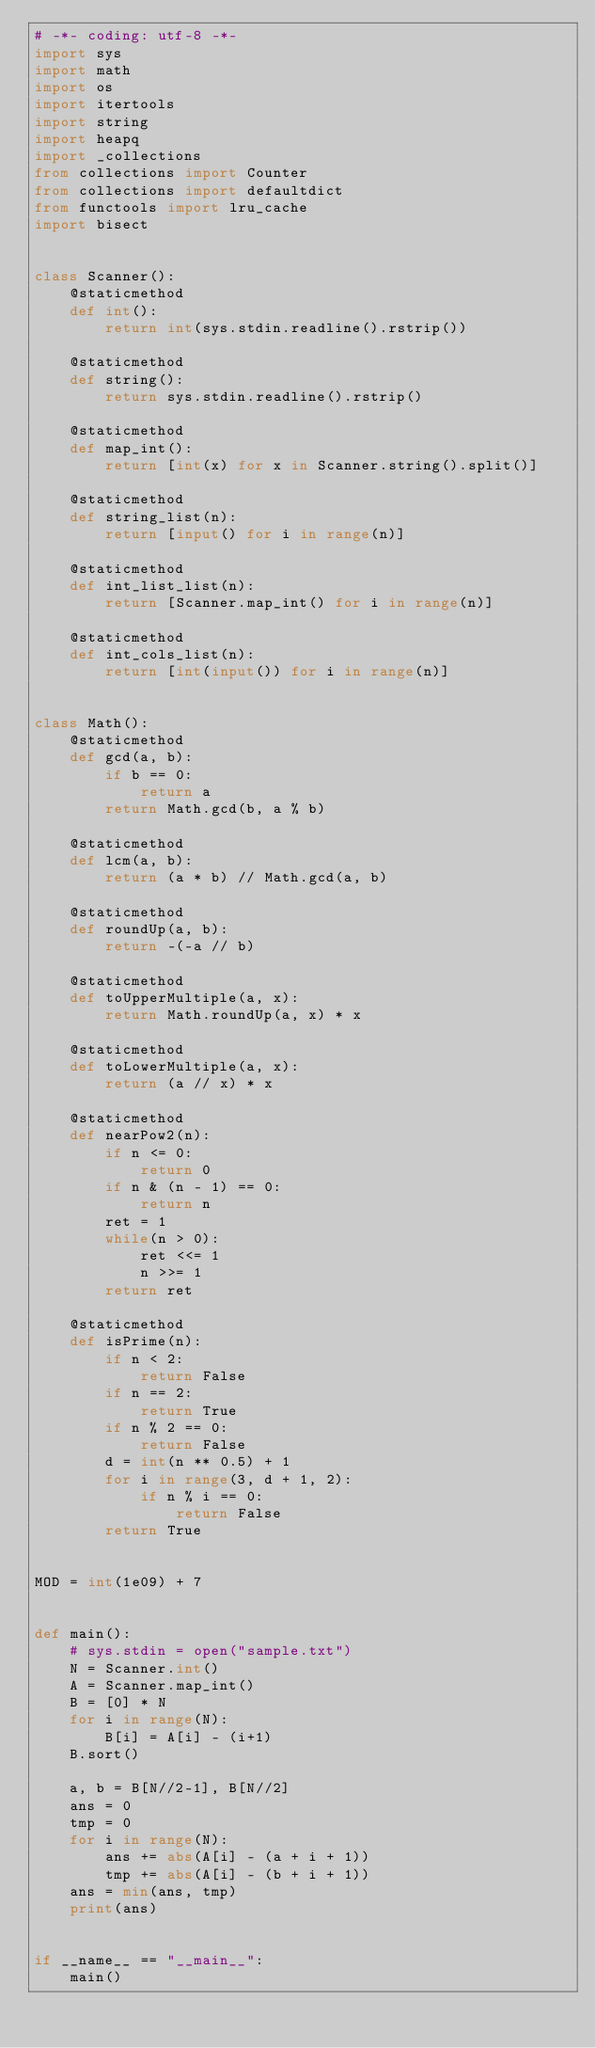Convert code to text. <code><loc_0><loc_0><loc_500><loc_500><_Python_># -*- coding: utf-8 -*-
import sys
import math
import os
import itertools
import string
import heapq
import _collections
from collections import Counter
from collections import defaultdict
from functools import lru_cache
import bisect


class Scanner():
    @staticmethod
    def int():
        return int(sys.stdin.readline().rstrip())

    @staticmethod
    def string():
        return sys.stdin.readline().rstrip()

    @staticmethod
    def map_int():
        return [int(x) for x in Scanner.string().split()]

    @staticmethod
    def string_list(n):
        return [input() for i in range(n)]

    @staticmethod
    def int_list_list(n):
        return [Scanner.map_int() for i in range(n)]

    @staticmethod
    def int_cols_list(n):
        return [int(input()) for i in range(n)]


class Math():
    @staticmethod
    def gcd(a, b):
        if b == 0:
            return a
        return Math.gcd(b, a % b)

    @staticmethod
    def lcm(a, b):
        return (a * b) // Math.gcd(a, b)

    @staticmethod
    def roundUp(a, b):
        return -(-a // b)

    @staticmethod
    def toUpperMultiple(a, x):
        return Math.roundUp(a, x) * x

    @staticmethod
    def toLowerMultiple(a, x):
        return (a // x) * x

    @staticmethod
    def nearPow2(n):
        if n <= 0:
            return 0
        if n & (n - 1) == 0:
            return n
        ret = 1
        while(n > 0):
            ret <<= 1
            n >>= 1
        return ret

    @staticmethod
    def isPrime(n):
        if n < 2:
            return False
        if n == 2:
            return True
        if n % 2 == 0:
            return False
        d = int(n ** 0.5) + 1
        for i in range(3, d + 1, 2):
            if n % i == 0:
                return False
        return True


MOD = int(1e09) + 7


def main():
    # sys.stdin = open("sample.txt")
    N = Scanner.int()
    A = Scanner.map_int()
    B = [0] * N
    for i in range(N):
        B[i] = A[i] - (i+1)
    B.sort()

    a, b = B[N//2-1], B[N//2]
    ans = 0
    tmp = 0
    for i in range(N):
        ans += abs(A[i] - (a + i + 1))
        tmp += abs(A[i] - (b + i + 1))
    ans = min(ans, tmp)
    print(ans)


if __name__ == "__main__":
    main()
</code> 